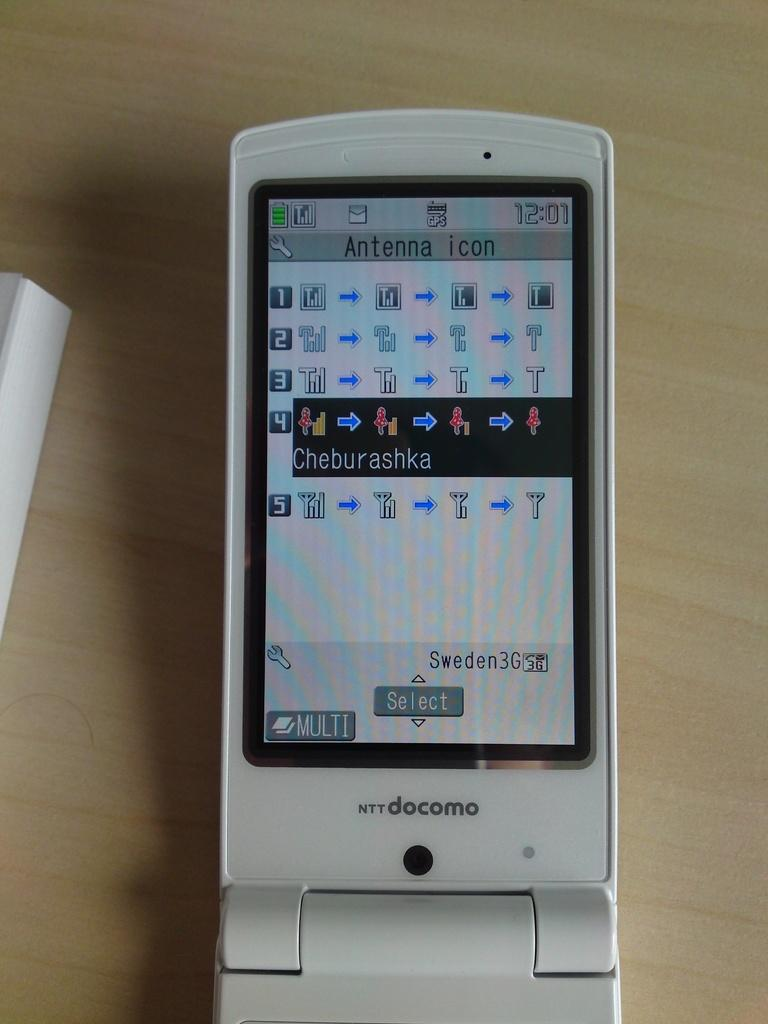What can be seen hanging in the image? There is a mobile in the image. What is the mobile attached to or placed on in the image? The mobile is on a wooden surface in the image. How does the visitor interact with the mobile in the image? There is no visitor present in the image, so it is not possible to determine how they might interact with the mobile. 